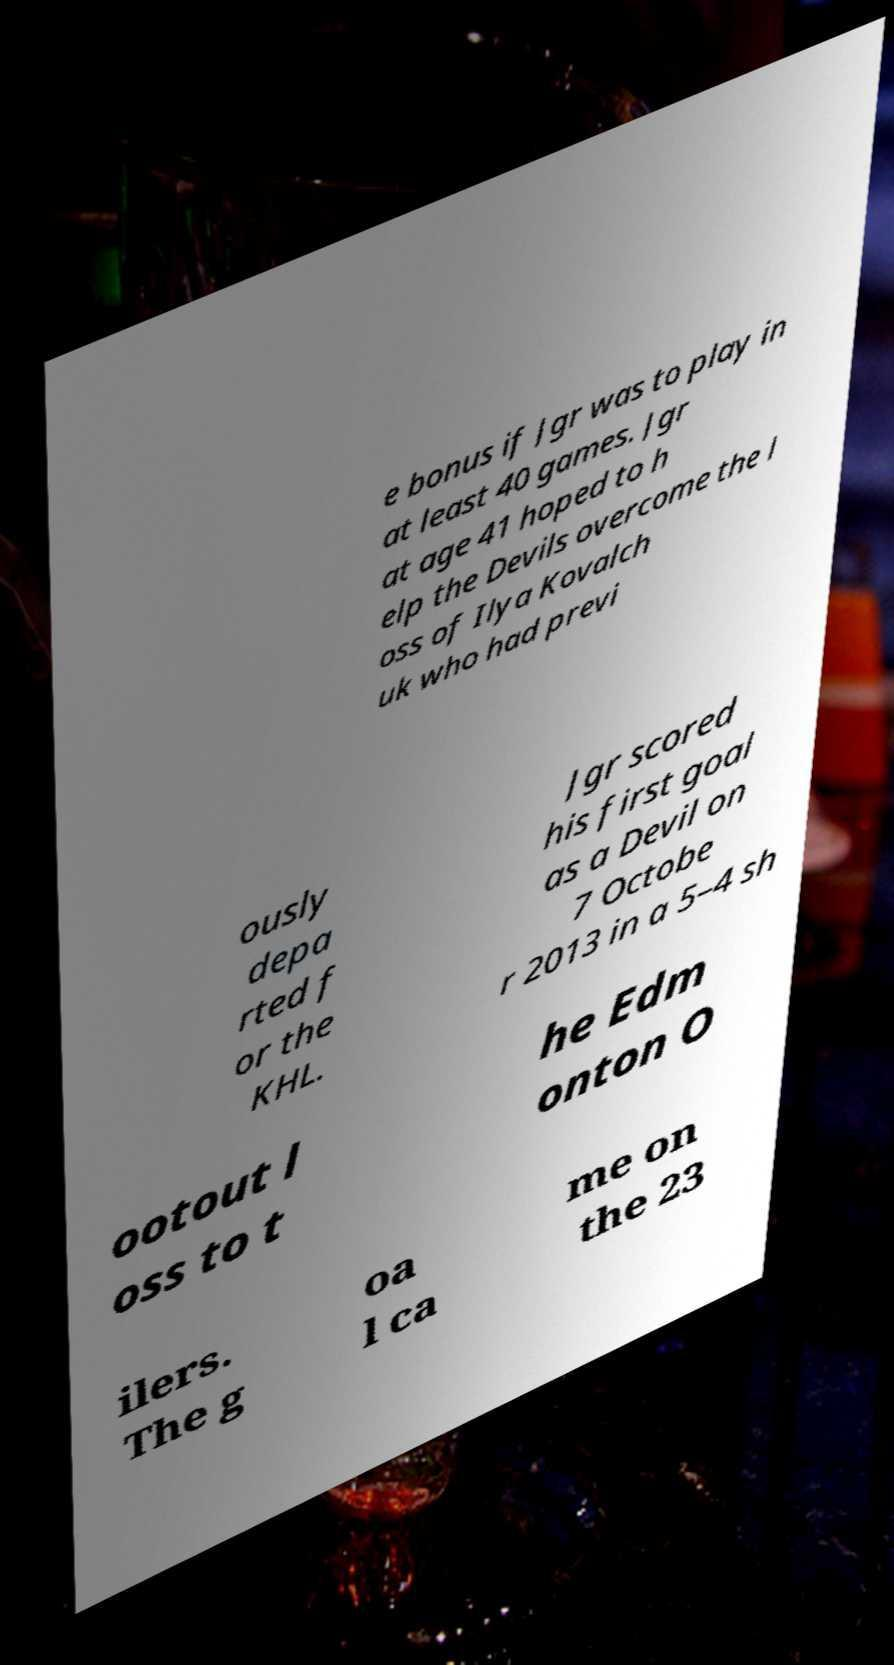For documentation purposes, I need the text within this image transcribed. Could you provide that? e bonus if Jgr was to play in at least 40 games. Jgr at age 41 hoped to h elp the Devils overcome the l oss of Ilya Kovalch uk who had previ ously depa rted f or the KHL. Jgr scored his first goal as a Devil on 7 Octobe r 2013 in a 5–4 sh ootout l oss to t he Edm onton O ilers. The g oa l ca me on the 23 